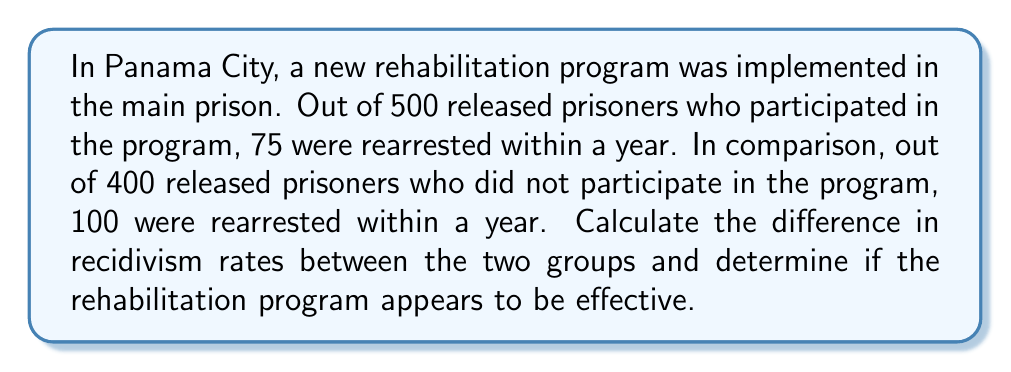Teach me how to tackle this problem. 1. Calculate the recidivism rate for the group that participated in the rehabilitation program:
   $$\text{Rate}_{\text{program}} = \frac{\text{Number rearrested}}{\text{Total released}} \times 100\%$$
   $$\text{Rate}_{\text{program}} = \frac{75}{500} \times 100\% = 15\%$$

2. Calculate the recidivism rate for the group that did not participate in the program:
   $$\text{Rate}_{\text{no program}} = \frac{\text{Number rearrested}}{\text{Total released}} \times 100\%$$
   $$\text{Rate}_{\text{no program}} = \frac{100}{400} \times 100\% = 25\%$$

3. Calculate the difference in recidivism rates:
   $$\text{Difference} = \text{Rate}_{\text{no program}} - \text{Rate}_{\text{program}}$$
   $$\text{Difference} = 25\% - 15\% = 10\%$$

4. Interpret the results:
   The rehabilitation program group has a 10 percentage point lower recidivism rate compared to the non-program group. This suggests that the rehabilitation program appears to be effective in reducing repeat offenses.
Answer: 10% lower recidivism rate; program appears effective 